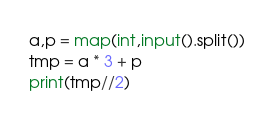<code> <loc_0><loc_0><loc_500><loc_500><_Python_>a,p = map(int,input().split())
tmp = a * 3 + p
print(tmp//2)</code> 